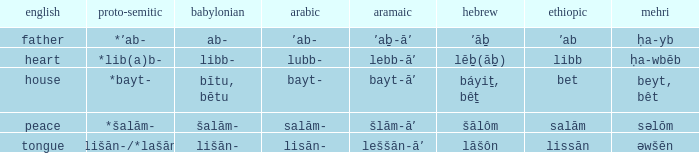If the proto-semitic is *bayt-, what are the geez? Bet. 